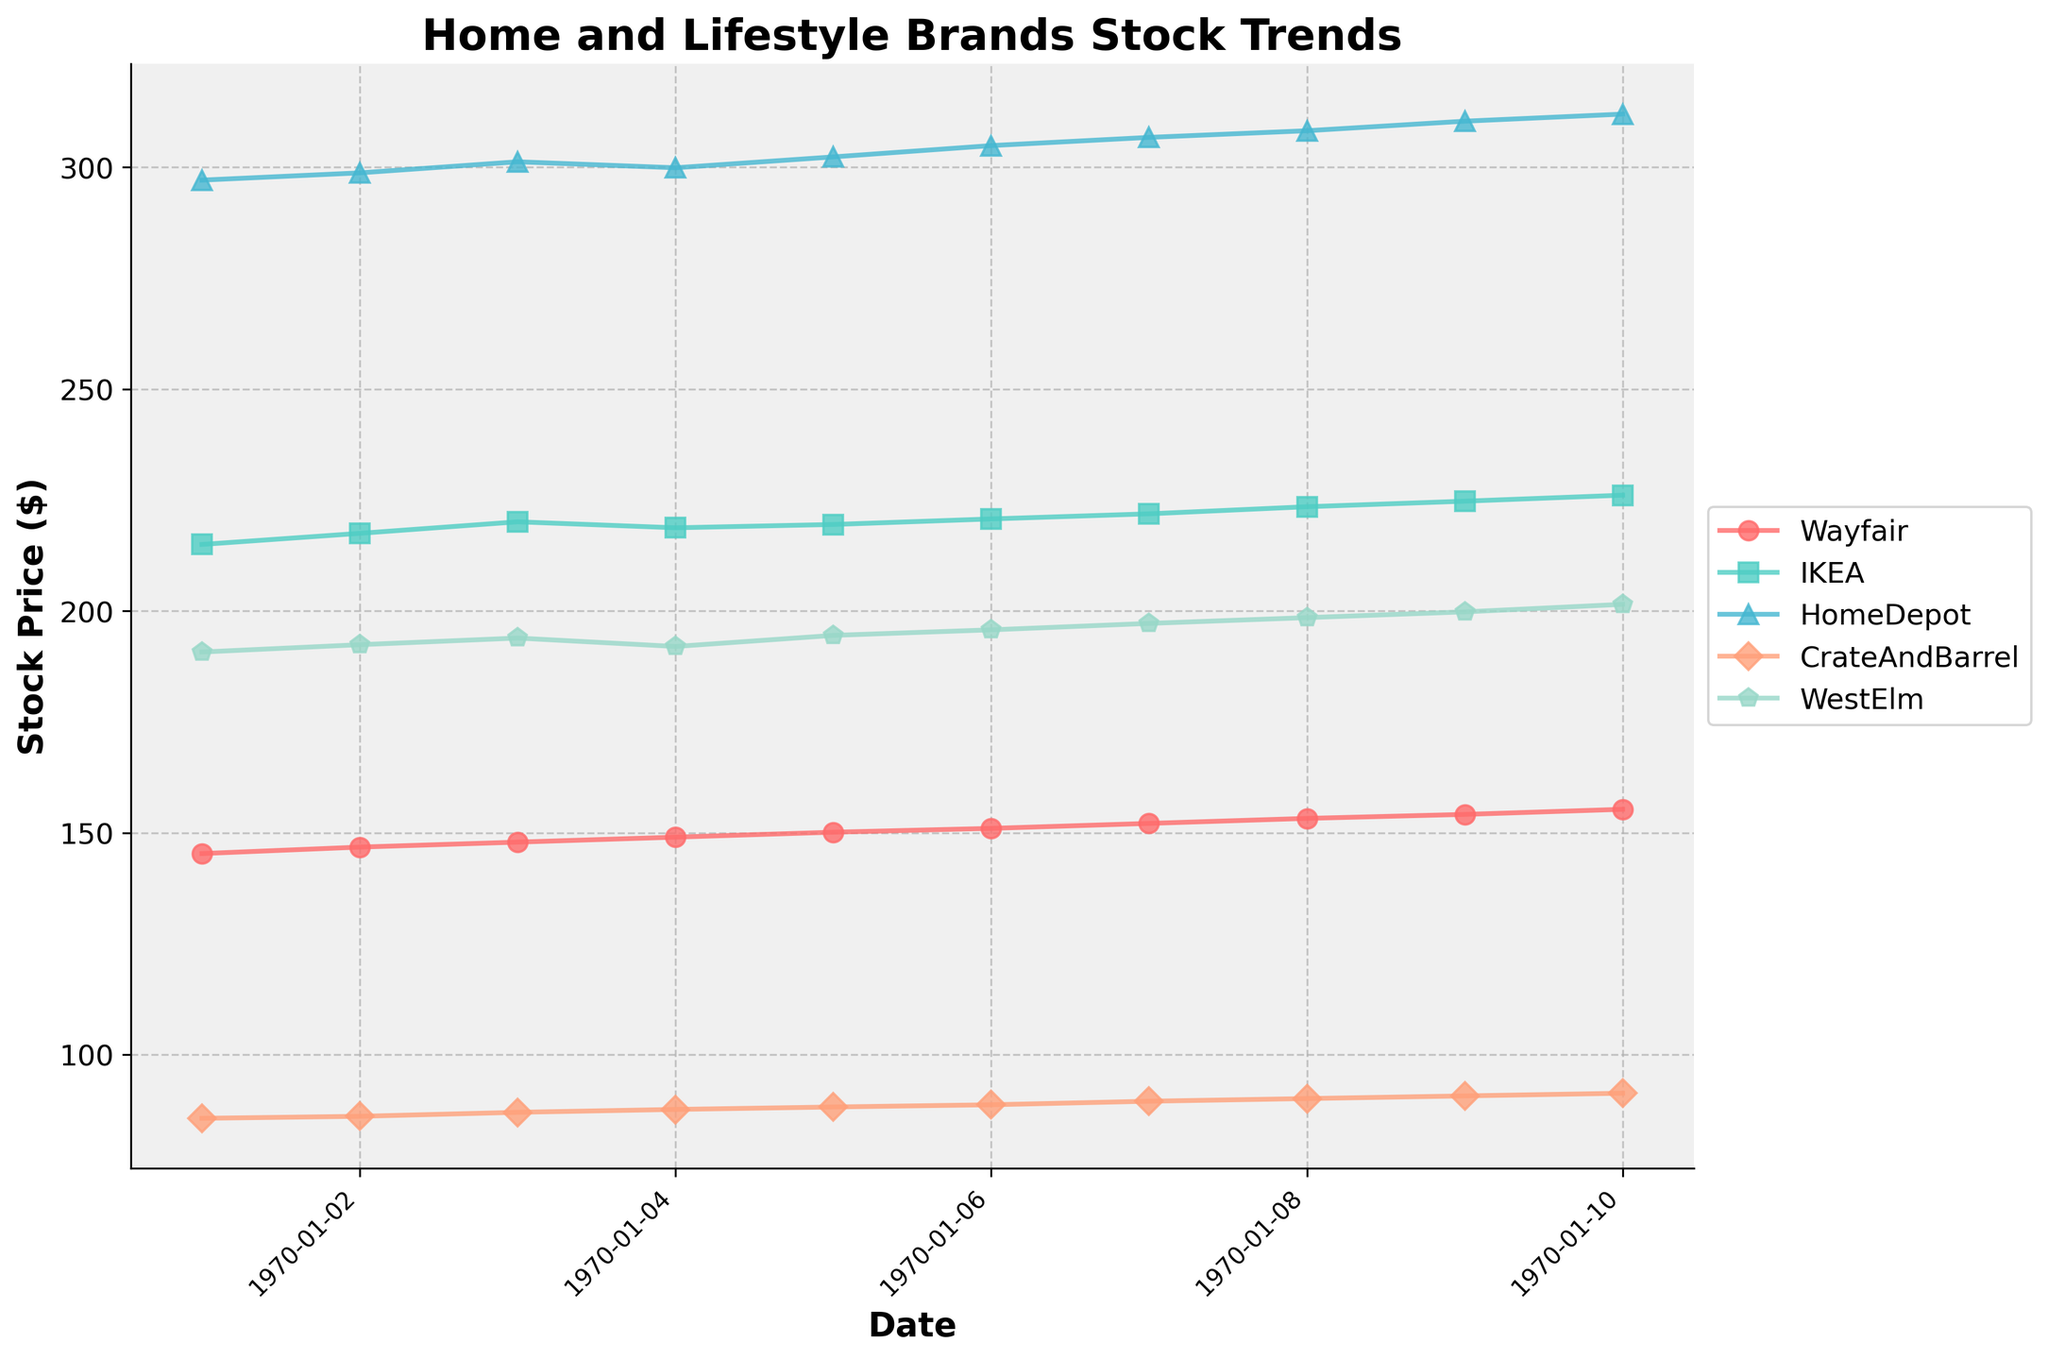What is the title of the plot? The title of the plot is usually shown at the top of the figure. In this plot, it is clearly stated at the top center.
Answer: Home and Lifestyle Brands Stock Trends How many different brands are displayed in the plot? There are different colored lines, each representing a brand. We can count these lines or look at the legend to identify the number of brands.
Answer: Five What is the color used for WestElm? The color representing WestElm can be identified by looking at the legend where colors of the lines are matched with the respective brands.
Answer: Green On what date did HomeDepot achieve its highest price during the period shown? By observing the HomeDepot line which is represented by its specific color, we can identify the highest point on the y-axis and its corresponding date on the x-axis.
Answer: 2023-01-10 Between Wayfair and CrateAndBarrel, which brand showed a more constant growth pattern? By comparing the slopes of the lines representing Wayfair and CrateAndBarrel, we can see which line has a more consistent upward trend.
Answer: Wayfair What is the total increase in stock price for IKEA from January 1, 2023, to January 10, 2023? We need to take the stock price of IKEA on January 10 and subtract the price on January 1.
Answer: 11.10 In which two-day period did WestElm's stock price increase the most? By examining the WestElm line and observing the y-axis values over each two-day period, we can determine the period with the greatest increase.
Answer: January 9 to January 10 Across all brands, which brand had its stock price rise the highest in a single day, and how much was the increase? By comparing the one-day increases for each brand across all days, we can identify the highest single-day increase and its value.
Answer: HomeDepot, 2.1 Which brand had the least variation in stock price over the given period? By observing the smoothness and range of the lines, we can determine which brand's line shows the least fluctuation.
Answer: IKEA What's the average stock price of CrateAndBarrel for the first five days of January 2023? We sum the stock prices of CrateAndBarrel from January 1 to January 5 and divide by the number of days. (85.65 + 86.10 + 87.00 + 87.65 + 88.20) / 5
Answer: 86.92 